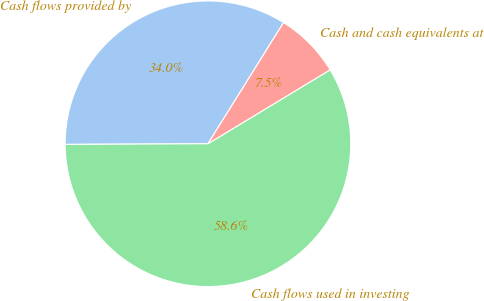Convert chart. <chart><loc_0><loc_0><loc_500><loc_500><pie_chart><fcel>Cash flows provided by<fcel>Cash flows used in investing<fcel>Cash and cash equivalents at<nl><fcel>33.95%<fcel>58.59%<fcel>7.46%<nl></chart> 